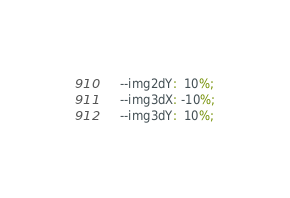<code> <loc_0><loc_0><loc_500><loc_500><_CSS_>	--img2dY:  10%;
	--img3dX: -10%;
	--img3dY:  10%;</code> 